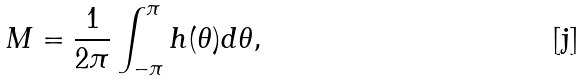Convert formula to latex. <formula><loc_0><loc_0><loc_500><loc_500>M = \frac { 1 } { 2 \pi } \int _ { - \pi } ^ { \pi } h ( \theta ) d \theta ,</formula> 